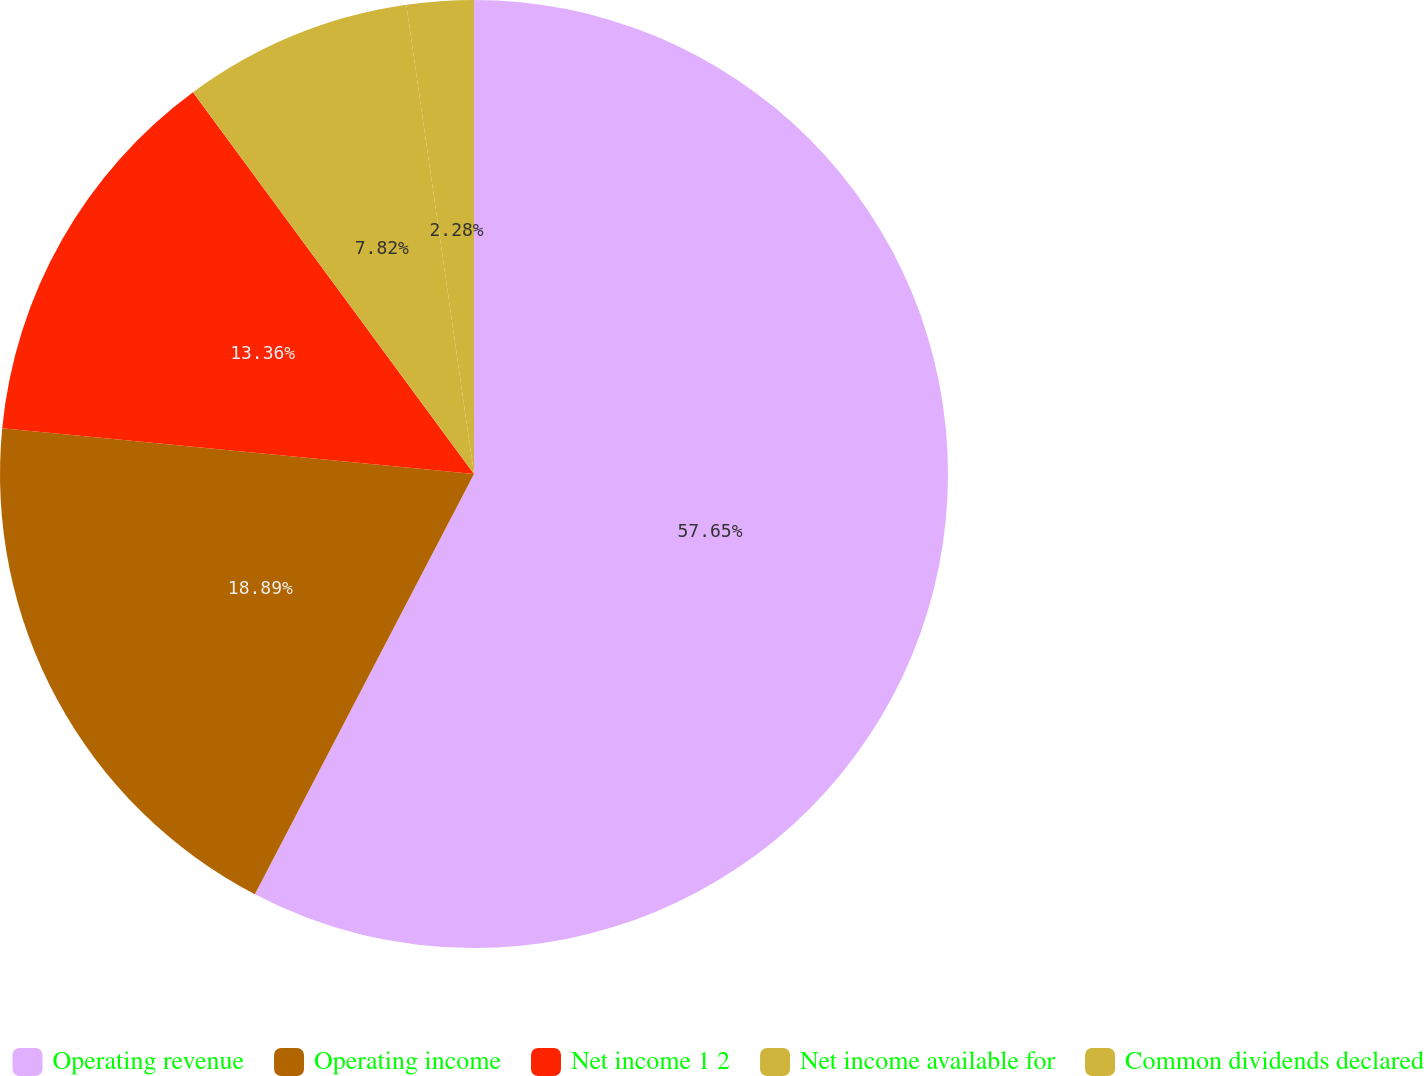Convert chart to OTSL. <chart><loc_0><loc_0><loc_500><loc_500><pie_chart><fcel>Operating revenue<fcel>Operating income<fcel>Net income 1 2<fcel>Net income available for<fcel>Common dividends declared<nl><fcel>57.65%<fcel>18.89%<fcel>13.36%<fcel>7.82%<fcel>2.28%<nl></chart> 